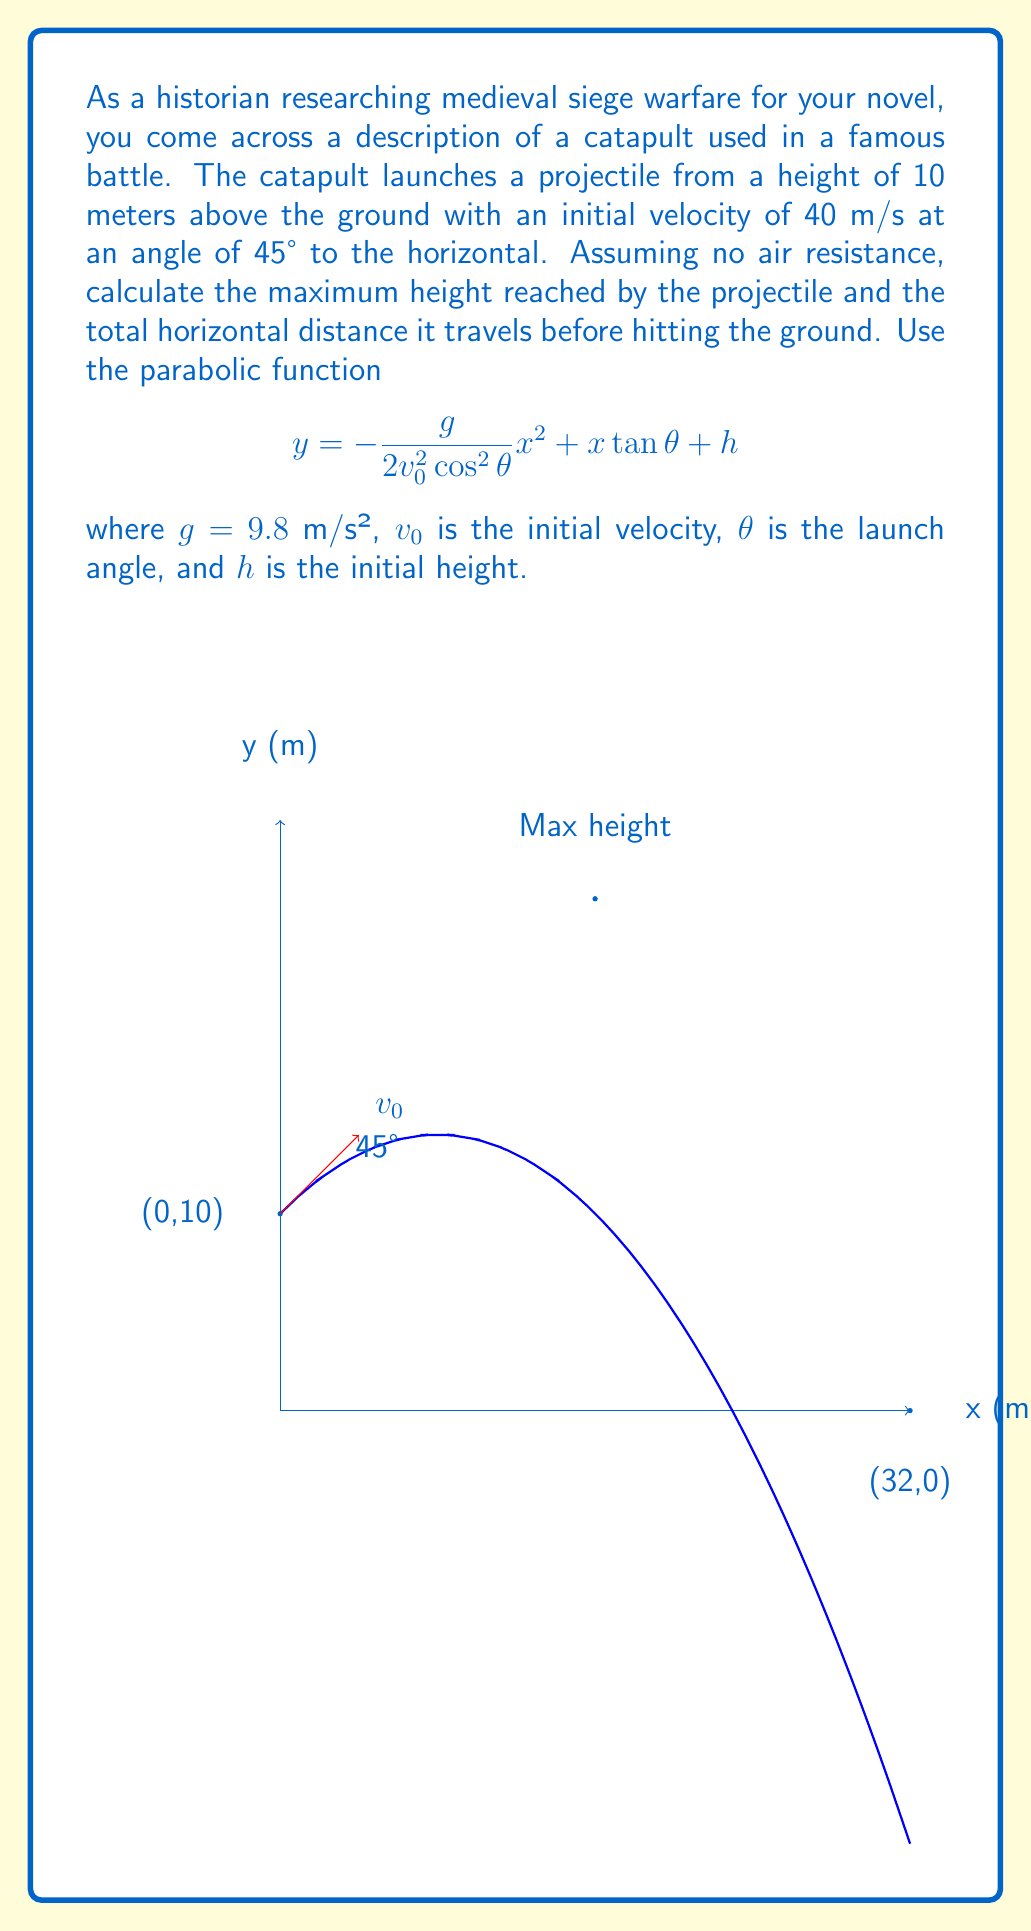Teach me how to tackle this problem. Let's approach this problem step-by-step:

1) First, we need to find the components of the initial velocity:
   $v_{0x} = v_0 \cos\theta = 40 \cos 45° = 40 \cdot \frac{\sqrt{2}}{2} \approx 28.28$ m/s
   $v_{0y} = v_0 \sin\theta = 40 \sin 45° = 40 \cdot \frac{\sqrt{2}}{2} \approx 28.28$ m/s

2) To find the maximum height, we use the equation:
   $y_{max} = h + \frac{v_{0y}^2}{2g}$
   $y_{max} = 10 + \frac{28.28^2}{2(9.8)} \approx 50.24$ m

3) The maximum height reached by the projectile above the ground is:
   $50.24 - 10 = 40.24$ m

4) For the horizontal distance, we use the time it takes for the projectile to reach the ground. We can find this using the quadratic equation:
   $y = -\frac{1}{2}gt^2 + v_{0y}t + h$
   $0 = -4.9t^2 + 28.28t + 10$

5) Solving this quadratic equation gives us:
   $t \approx 6.53$ seconds

6) Now we can calculate the horizontal distance:
   $x = v_{0x}t = 28.28 \cdot 6.53 \approx 184.67$ m

Therefore, the projectile reaches a maximum height of 40.24 m above its starting point and travels a horizontal distance of 184.67 m.
Answer: Maximum height above starting point: 40.24 m; Horizontal distance: 184.67 m 